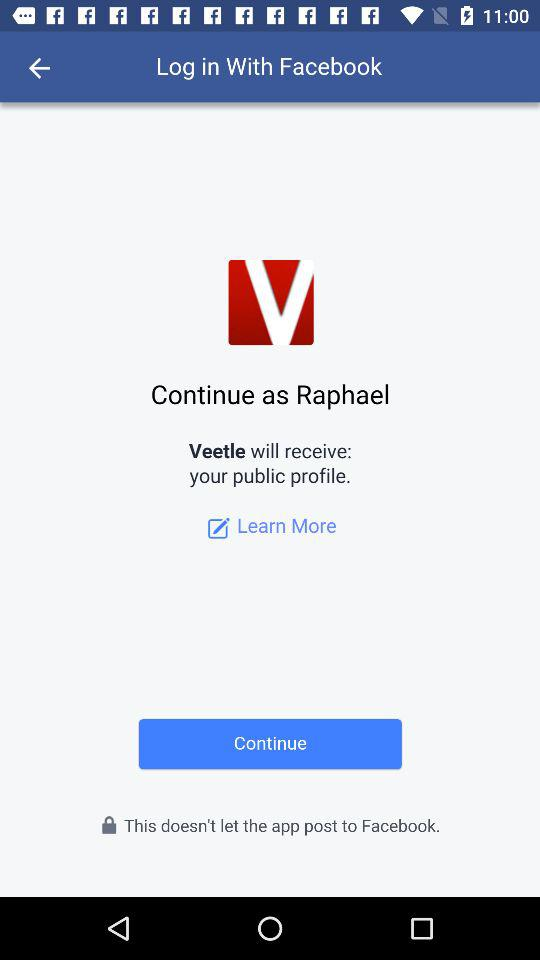What information will "Veetle" receive? "Veetle" will receive your "public profile". 